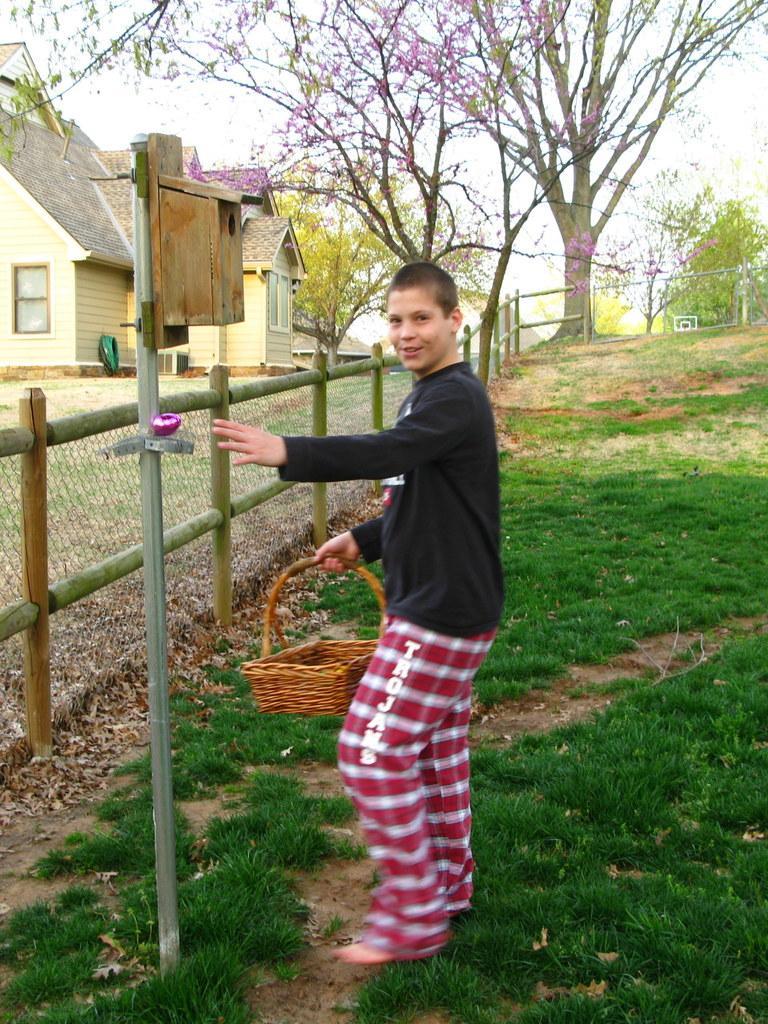Can you describe this image briefly? In the middle of the image a boy is standing and holding a basket. Behind him there is grass and pole and fencing. Behind the fencing there are some trees and buildings. 